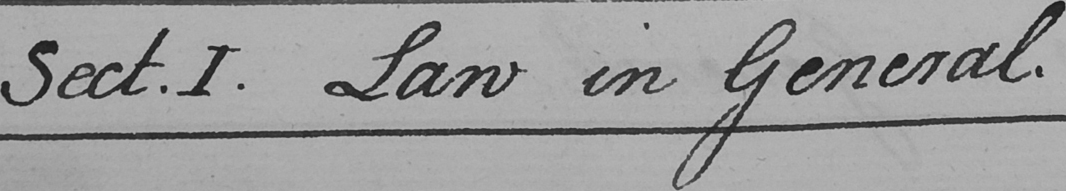What is written in this line of handwriting? Sect.I . Law in General . 